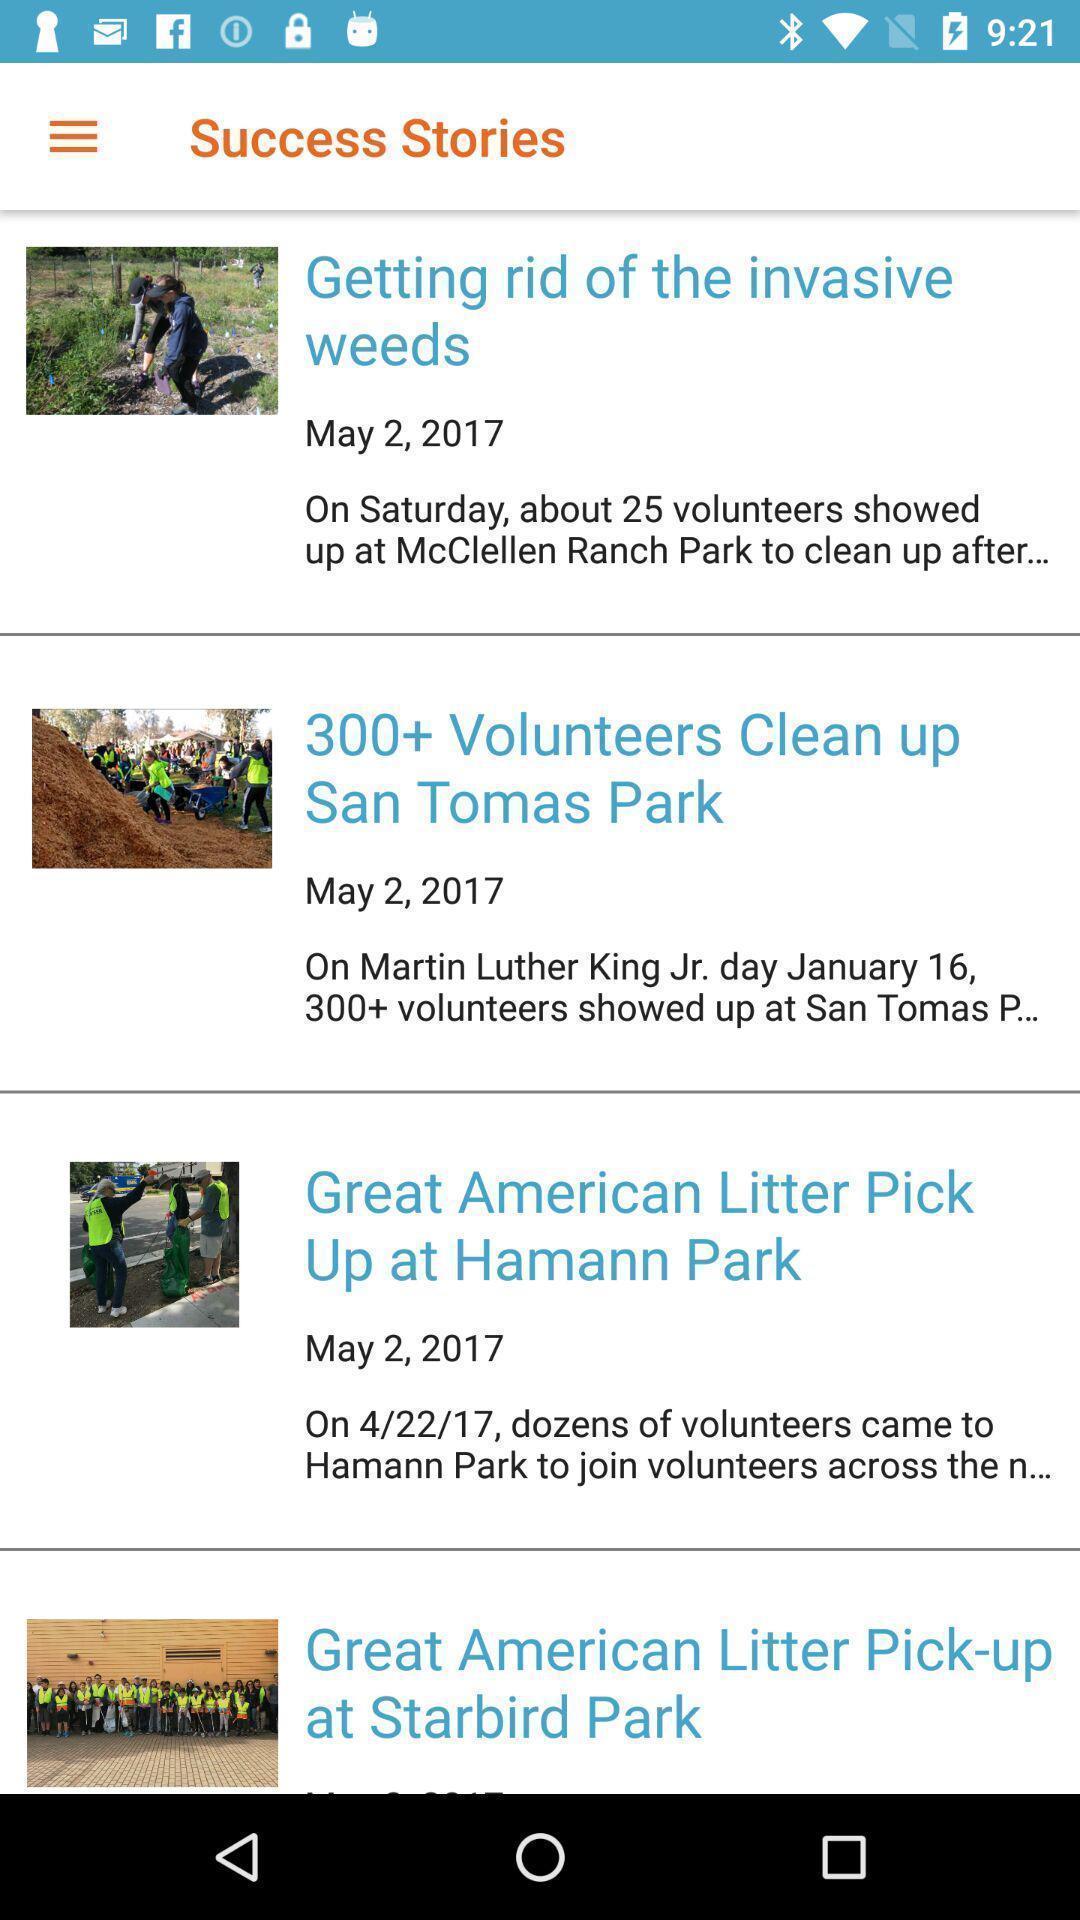Provide a detailed account of this screenshot. Stories are displaying in the news page. 